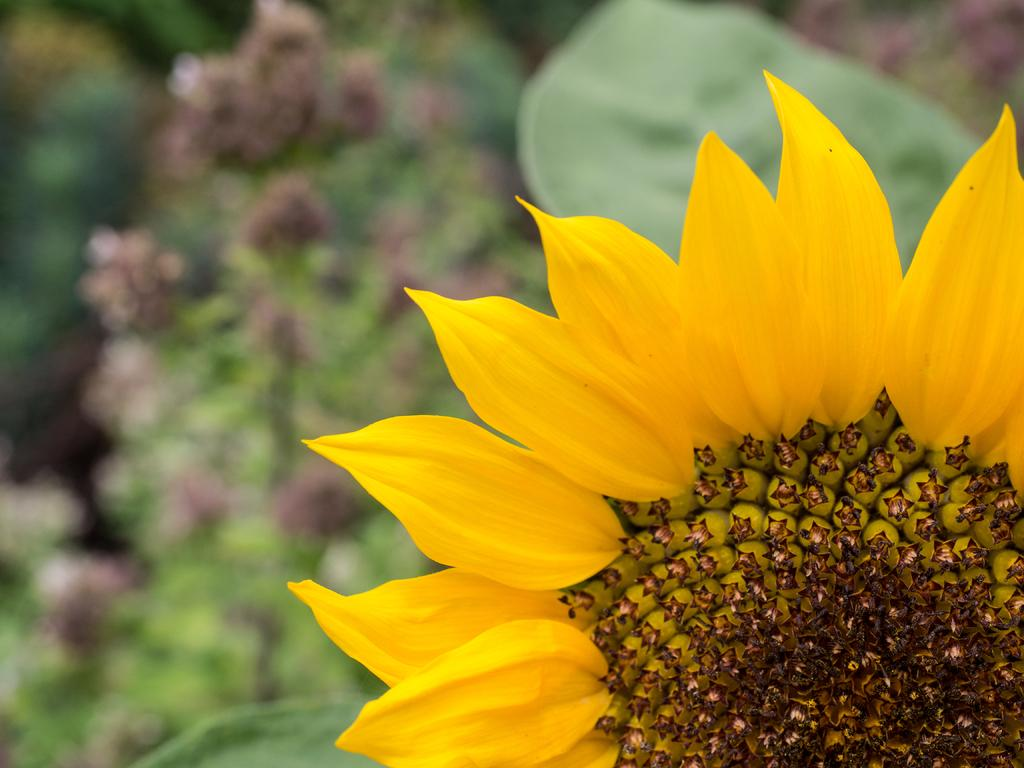What is the main subject of the picture? The main subject of the picture is a flower. Can you describe the color of the flower? The flower is yellow in color. What are the main parts of the flower? The flower has petals. What else can be seen in the background of the picture? There are plants with flowers visible in the background. What type of watch is the flower wearing in the image? There is no watch present in the image; it features a flower with petals. How does the flower use the wheel to move around in the image? There is no wheel present in the image, and flowers do not move around on their own. 